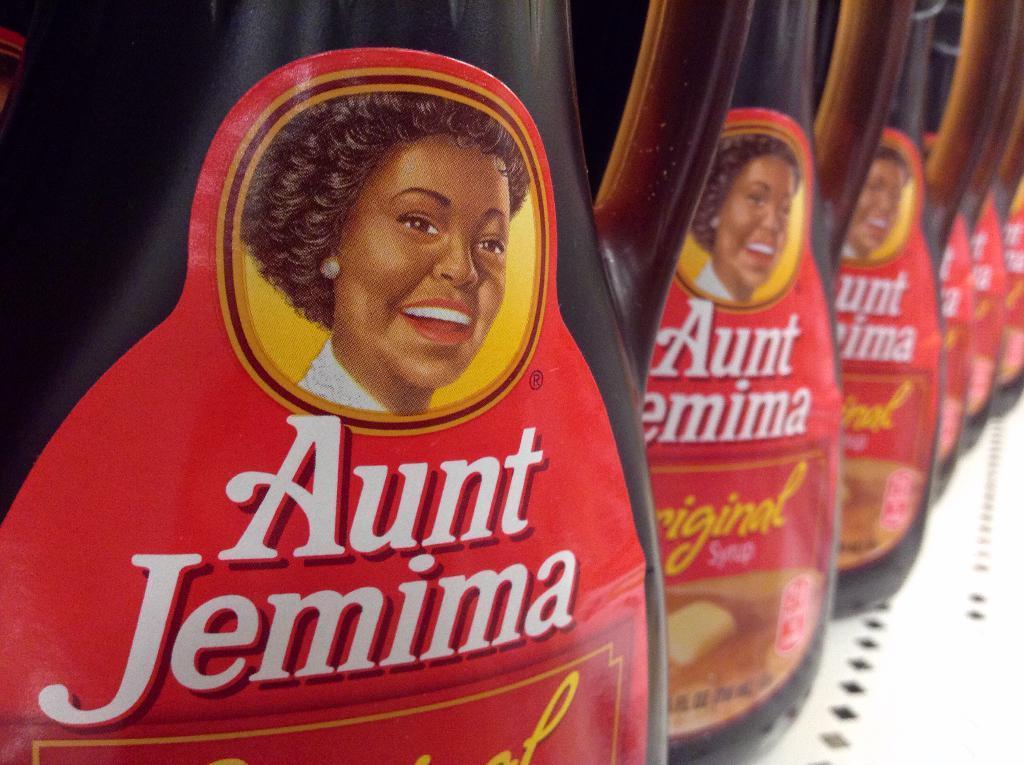Could you give a brief overview of what you see in this image? In this image we can see bottles placed on the surface. 